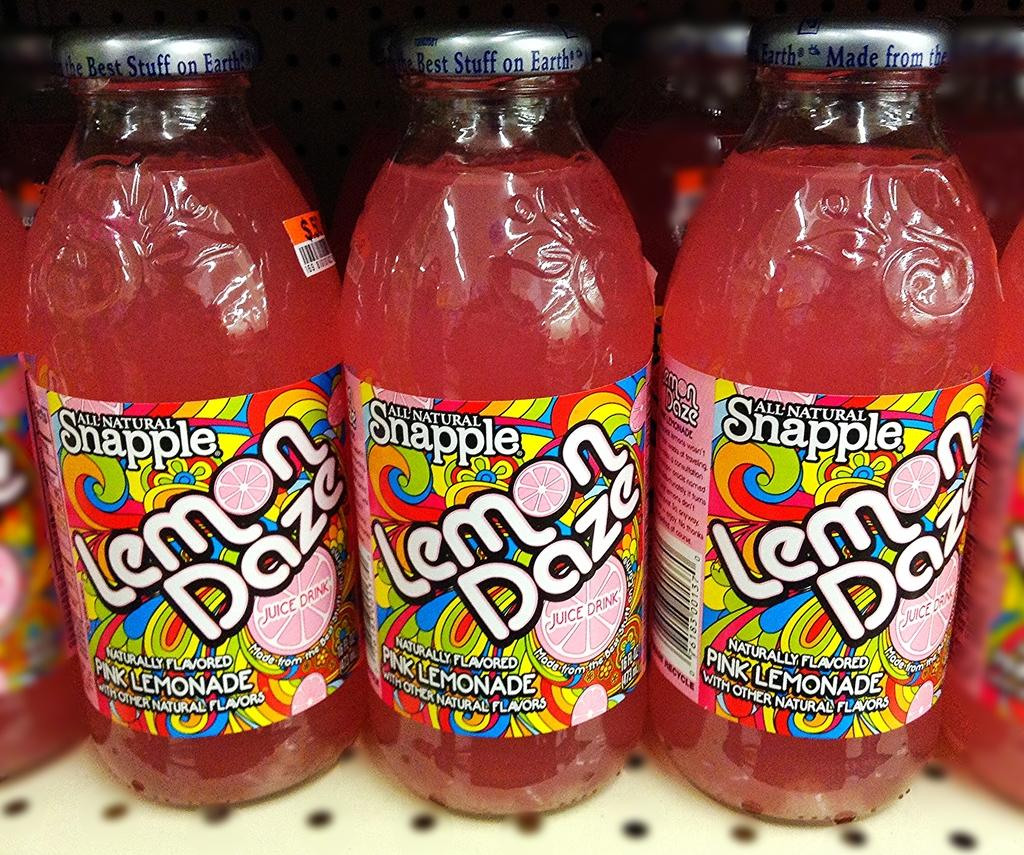Provide a one-sentence caption for the provided image. Bottles of Snapple Lemon Daze are on a shelf. 